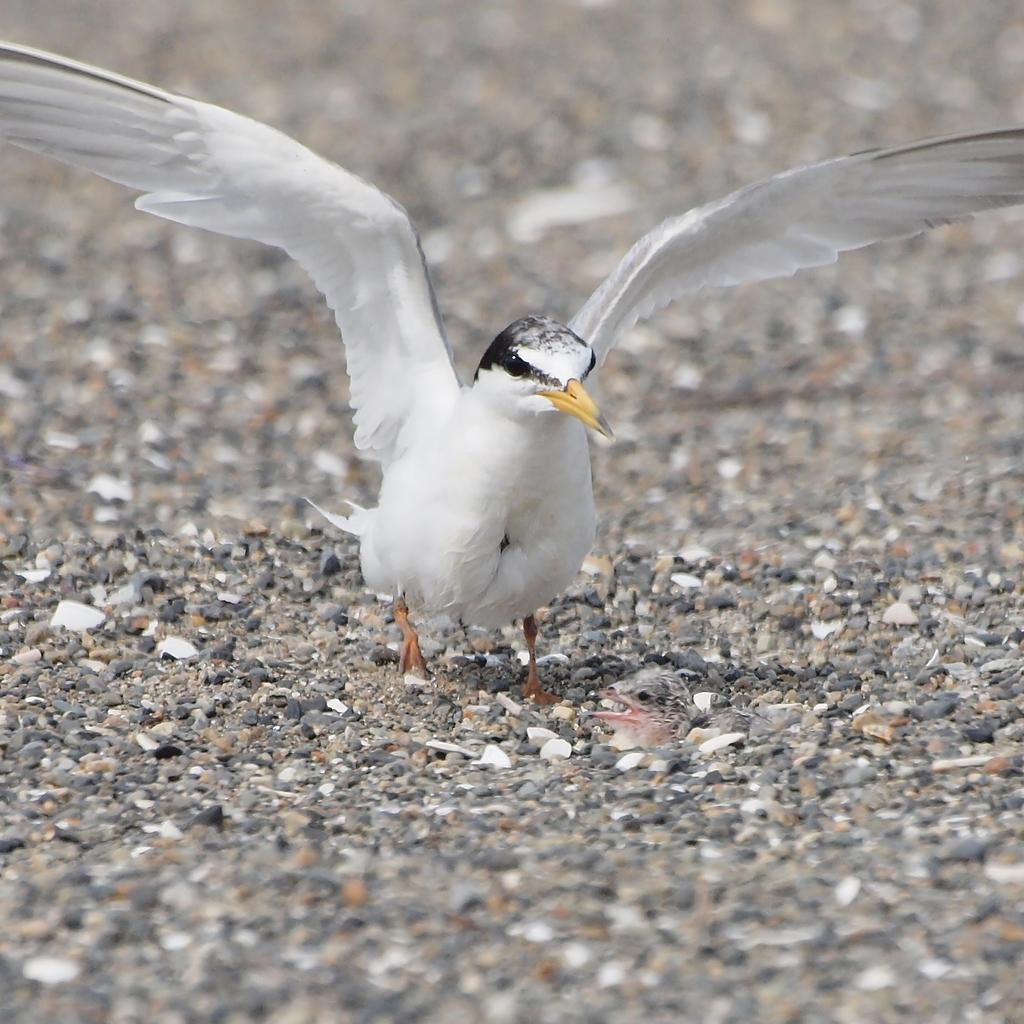In one or two sentences, can you explain what this image depicts? In the image there is a bird on the stone surface. 